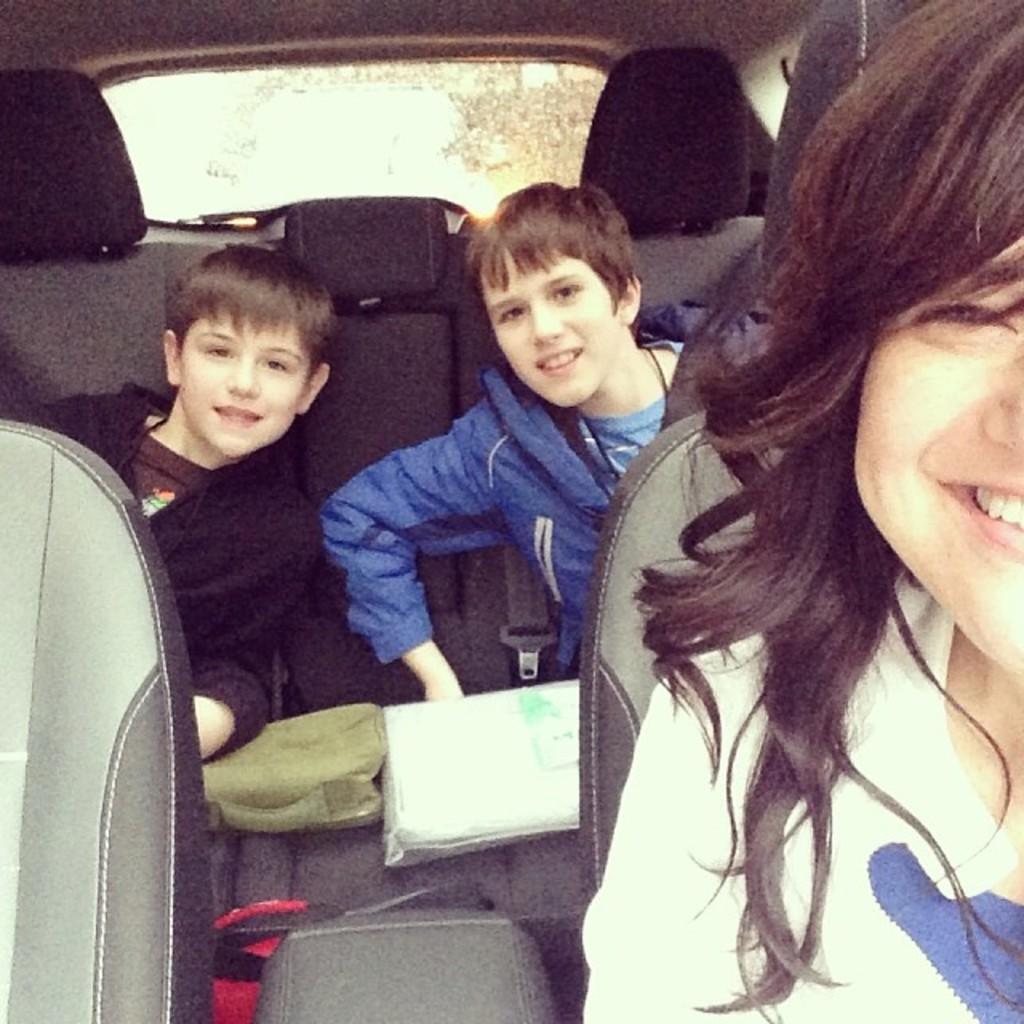Please provide a concise description of this image. In this image I can see three people sitting in the vehicle. I can see these people are wearing the different color dresses. In the background I can see the trees through the glass. 